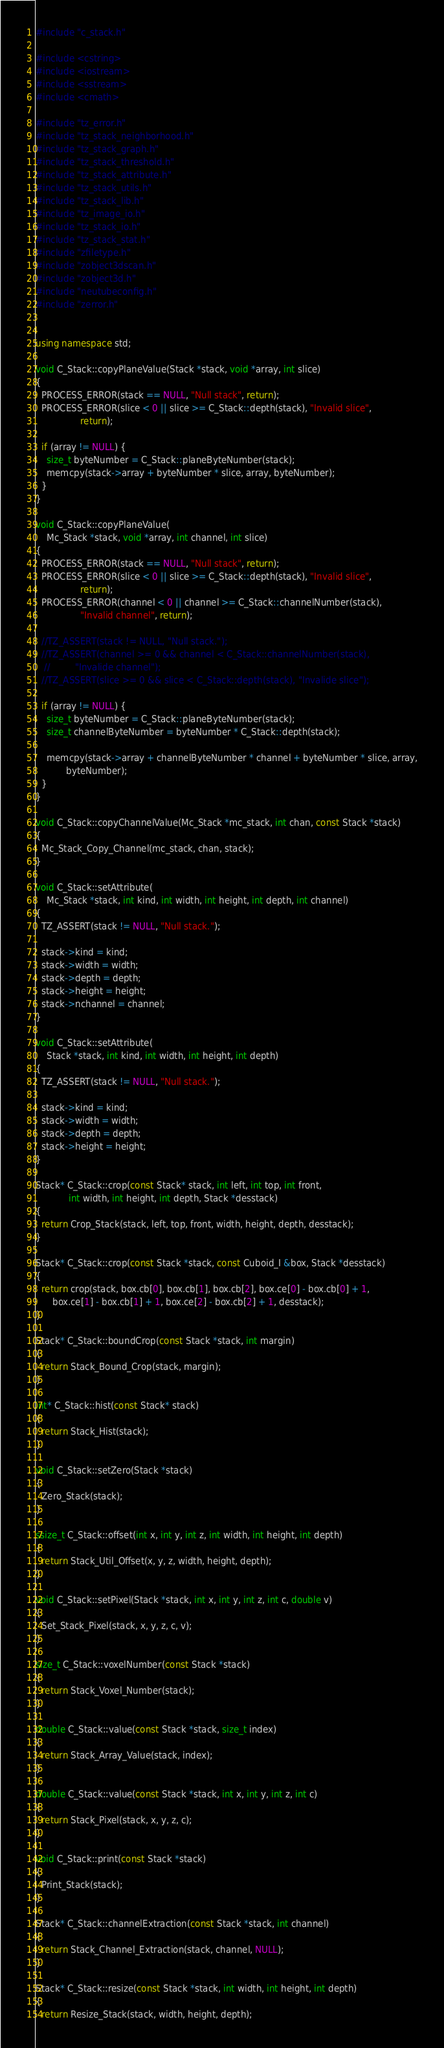Convert code to text. <code><loc_0><loc_0><loc_500><loc_500><_C++_>#include "c_stack.h"

#include <cstring>
#include <iostream>
#include <sstream>
#include <cmath>

#include "tz_error.h"
#include "tz_stack_neighborhood.h"
#include "tz_stack_graph.h"
#include "tz_stack_threshold.h"
#include "tz_stack_attribute.h"
#include "tz_stack_utils.h"
#include "tz_stack_lib.h"
#include "tz_image_io.h"
#include "tz_stack_io.h"
#include "tz_stack_stat.h"
#include "zfiletype.h"
#include "zobject3dscan.h"
#include "zobject3d.h"
#include "neutubeconfig.h"
#include "zerror.h"


using namespace std;

void C_Stack::copyPlaneValue(Stack *stack, void *array, int slice)
{
  PROCESS_ERROR(stack == NULL, "Null stack", return);
  PROCESS_ERROR(slice < 0 || slice >= C_Stack::depth(stack), "Invalid slice",
                return);

  if (array != NULL) {
    size_t byteNumber = C_Stack::planeByteNumber(stack);
    memcpy(stack->array + byteNumber * slice, array, byteNumber);
  }
}

void C_Stack::copyPlaneValue(
    Mc_Stack *stack, void *array, int channel, int slice)
{
  PROCESS_ERROR(stack == NULL, "Null stack", return);
  PROCESS_ERROR(slice < 0 || slice >= C_Stack::depth(stack), "Invalid slice",
                return);
  PROCESS_ERROR(channel < 0 || channel >= C_Stack::channelNumber(stack),
                "Invalid channel", return);

  //TZ_ASSERT(stack != NULL, "Null stack.");
  //TZ_ASSERT(channel >= 0 && channel < C_Stack::channelNumber(stack),
   //         "Invalide channel");
  //TZ_ASSERT(slice >= 0 && slice < C_Stack::depth(stack), "Invalide slice");

  if (array != NULL) {
    size_t byteNumber = C_Stack::planeByteNumber(stack);
    size_t channelByteNumber = byteNumber * C_Stack::depth(stack);

    memcpy(stack->array + channelByteNumber * channel + byteNumber * slice, array,
           byteNumber);
  }
}

void C_Stack::copyChannelValue(Mc_Stack *mc_stack, int chan, const Stack *stack)
{
  Mc_Stack_Copy_Channel(mc_stack, chan, stack);
}

void C_Stack::setAttribute(
    Mc_Stack *stack, int kind, int width, int height, int depth, int channel)
{
  TZ_ASSERT(stack != NULL, "Null stack.");

  stack->kind = kind;
  stack->width = width;
  stack->depth = depth;
  stack->height = height;
  stack->nchannel = channel;
}

void C_Stack::setAttribute(
    Stack *stack, int kind, int width, int height, int depth)
{
  TZ_ASSERT(stack != NULL, "Null stack.");

  stack->kind = kind;
  stack->width = width;
  stack->depth = depth;
  stack->height = height;
}

Stack* C_Stack::crop(const Stack* stack, int left, int top, int front,
            int width, int height, int depth, Stack *desstack)
{
  return Crop_Stack(stack, left, top, front, width, height, depth, desstack);
}

Stack* C_Stack::crop(const Stack *stack, const Cuboid_I &box, Stack *desstack)
{
  return crop(stack, box.cb[0], box.cb[1], box.cb[2], box.ce[0] - box.cb[0] + 1,
      box.ce[1] - box.cb[1] + 1, box.ce[2] - box.cb[2] + 1, desstack);
}

Stack* C_Stack::boundCrop(const Stack *stack, int margin)
{
  return Stack_Bound_Crop(stack, margin);
}

int* C_Stack::hist(const Stack* stack)
{
  return Stack_Hist(stack);
}

void C_Stack::setZero(Stack *stack)
{
  Zero_Stack(stack);
}

ssize_t C_Stack::offset(int x, int y, int z, int width, int height, int depth)
{
  return Stack_Util_Offset(x, y, z, width, height, depth);
}

void C_Stack::setPixel(Stack *stack, int x, int y, int z, int c, double v)
{
  Set_Stack_Pixel(stack, x, y, z, c, v);
}

size_t C_Stack::voxelNumber(const Stack *stack)
{
  return Stack_Voxel_Number(stack);
}

double C_Stack::value(const Stack *stack, size_t index)
{
  return Stack_Array_Value(stack, index);
}

double C_Stack::value(const Stack *stack, int x, int y, int z, int c)
{
  return Stack_Pixel(stack, x, y, z, c);
}

void C_Stack::print(const Stack *stack)
{
  Print_Stack(stack);
}

Stack* C_Stack::channelExtraction(const Stack *stack, int channel)
{
  return Stack_Channel_Extraction(stack, channel, NULL);
}

Stack* C_Stack::resize(const Stack *stack, int width, int height, int depth)
{
  return Resize_Stack(stack, width, height, depth);</code> 